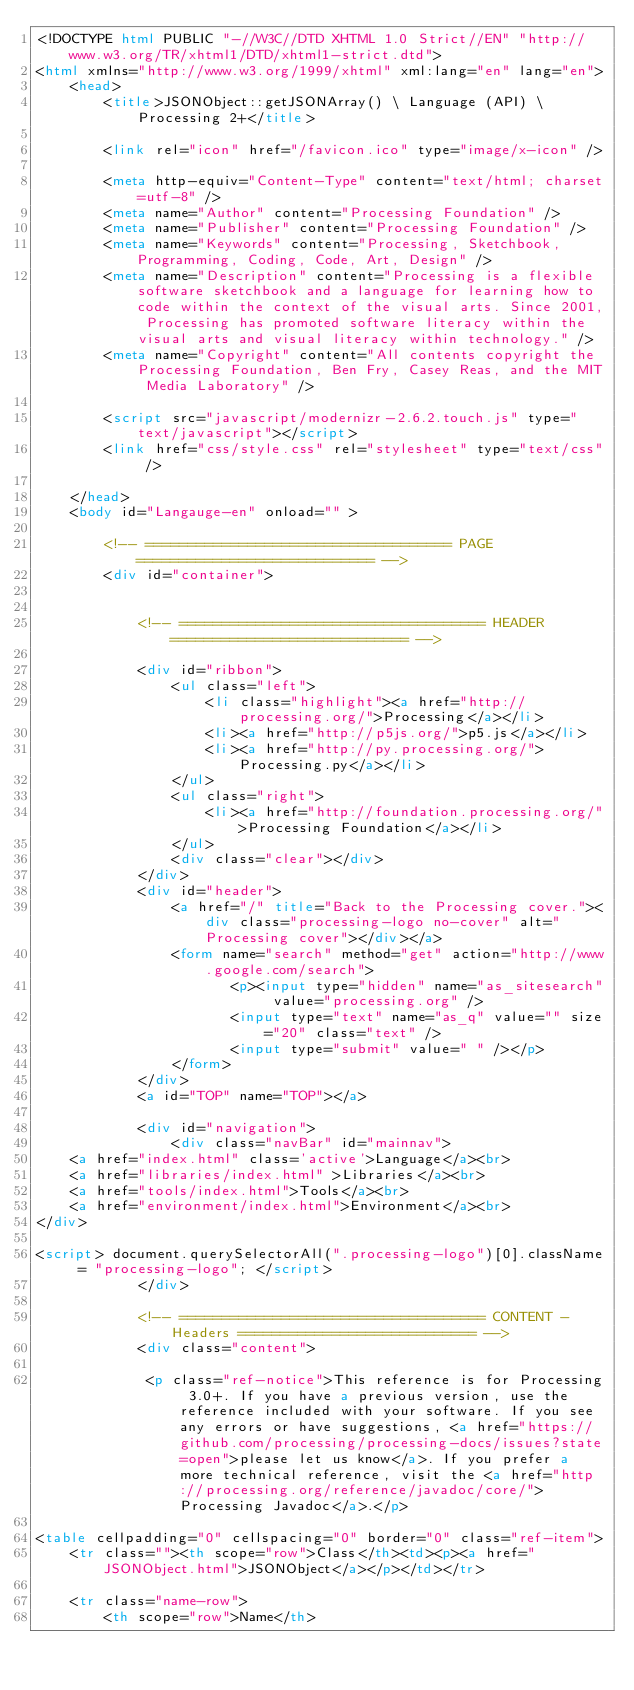<code> <loc_0><loc_0><loc_500><loc_500><_HTML_><!DOCTYPE html PUBLIC "-//W3C//DTD XHTML 1.0 Strict//EN" "http://www.w3.org/TR/xhtml1/DTD/xhtml1-strict.dtd">
<html xmlns="http://www.w3.org/1999/xhtml" xml:lang="en" lang="en">
	<head>
		<title>JSONObject::getJSONArray() \ Language (API) \ Processing 2+</title>

		<link rel="icon" href="/favicon.ico" type="image/x-icon" />

		<meta http-equiv="Content-Type" content="text/html; charset=utf-8" />
		<meta name="Author" content="Processing Foundation" />
		<meta name="Publisher" content="Processing Foundation" />
		<meta name="Keywords" content="Processing, Sketchbook, Programming, Coding, Code, Art, Design" />
		<meta name="Description" content="Processing is a flexible software sketchbook and a language for learning how to code within the context of the visual arts. Since 2001, Processing has promoted software literacy within the visual arts and visual literacy within technology." />
		<meta name="Copyright" content="All contents copyright the Processing Foundation, Ben Fry, Casey Reas, and the MIT Media Laboratory" />

		<script src="javascript/modernizr-2.6.2.touch.js" type="text/javascript"></script>
		<link href="css/style.css" rel="stylesheet" type="text/css" />

	</head>
	<body id="Langauge-en" onload="" >

		<!-- ==================================== PAGE ============================ -->
		<div id="container">


			<!-- ==================================== HEADER ============================ -->

			<div id="ribbon">
				<ul class="left">
					<li class="highlight"><a href="http://processing.org/">Processing</a></li>
					<li><a href="http://p5js.org/">p5.js</a></li>
					<li><a href="http://py.processing.org/">Processing.py</a></li>
				</ul>
				<ul class="right">
					<li><a href="http://foundation.processing.org/">Processing Foundation</a></li>
				</ul>
				<div class="clear"></div>
			</div>
			<div id="header">
				<a href="/" title="Back to the Processing cover."><div class="processing-logo no-cover" alt="Processing cover"></div></a>
				<form name="search" method="get" action="http://www.google.com/search">
				       <p><input type="hidden" name="as_sitesearch" value="processing.org" />
				       <input type="text" name="as_q" value="" size="20" class="text" />
				       <input type="submit" value=" " /></p>
				</form>
			</div>
			<a id="TOP" name="TOP"></a>

			<div id="navigation">
				<div class="navBar" id="mainnav">
	<a href="index.html" class='active'>Language</a><br>
	<a href="libraries/index.html" >Libraries</a><br>
	<a href="tools/index.html">Tools</a><br>
	<a href="environment/index.html">Environment</a><br>
</div>

<script> document.querySelectorAll(".processing-logo")[0].className = "processing-logo"; </script>
			</div>

			<!-- ==================================== CONTENT - Headers ============================ -->
			<div class="content">

			 <p class="ref-notice">This reference is for Processing 3.0+. If you have a previous version, use the reference included with your software. If you see any errors or have suggestions, <a href="https://github.com/processing/processing-docs/issues?state=open">please let us know</a>. If you prefer a more technical reference, visit the <a href="http://processing.org/reference/javadoc/core/">Processing Javadoc</a>.</p>

<table cellpadding="0" cellspacing="0" border="0" class="ref-item">
	<tr class=""><th scope="row">Class</th><td><p><a href="JSONObject.html">JSONObject</a></p></td></tr>

	<tr class="name-row">
		<th scope="row">Name</th>
</code> 